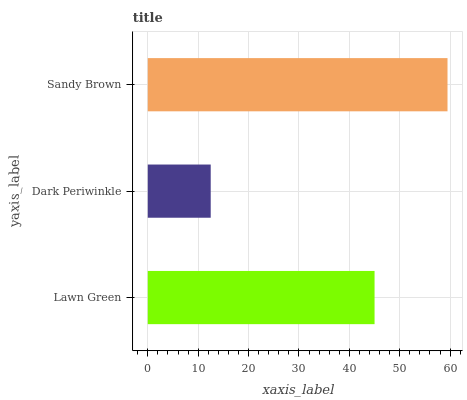Is Dark Periwinkle the minimum?
Answer yes or no. Yes. Is Sandy Brown the maximum?
Answer yes or no. Yes. Is Sandy Brown the minimum?
Answer yes or no. No. Is Dark Periwinkle the maximum?
Answer yes or no. No. Is Sandy Brown greater than Dark Periwinkle?
Answer yes or no. Yes. Is Dark Periwinkle less than Sandy Brown?
Answer yes or no. Yes. Is Dark Periwinkle greater than Sandy Brown?
Answer yes or no. No. Is Sandy Brown less than Dark Periwinkle?
Answer yes or no. No. Is Lawn Green the high median?
Answer yes or no. Yes. Is Lawn Green the low median?
Answer yes or no. Yes. Is Sandy Brown the high median?
Answer yes or no. No. Is Dark Periwinkle the low median?
Answer yes or no. No. 